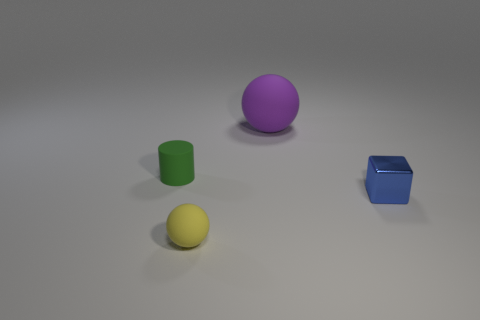Is there anything else that is the same material as the small blue thing?
Ensure brevity in your answer.  No. How many objects are either balls behind the tiny cube or matte spheres that are in front of the large purple rubber thing?
Give a very brief answer. 2. What number of metallic things are to the right of the matte sphere that is in front of the small blue shiny cube?
Your response must be concise. 1. The big sphere that is the same material as the tiny ball is what color?
Your answer should be compact. Purple. Is there a rubber ball of the same size as the cylinder?
Offer a terse response. Yes. The rubber thing that is the same size as the yellow rubber ball is what shape?
Ensure brevity in your answer.  Cylinder. Is there a yellow rubber thing that has the same shape as the purple object?
Keep it short and to the point. Yes. Are the big purple sphere and the small object that is right of the purple thing made of the same material?
Ensure brevity in your answer.  No. How many other objects are the same material as the block?
Your answer should be very brief. 0. Is the number of cylinders on the left side of the big thing greater than the number of small gray matte balls?
Give a very brief answer. Yes. 